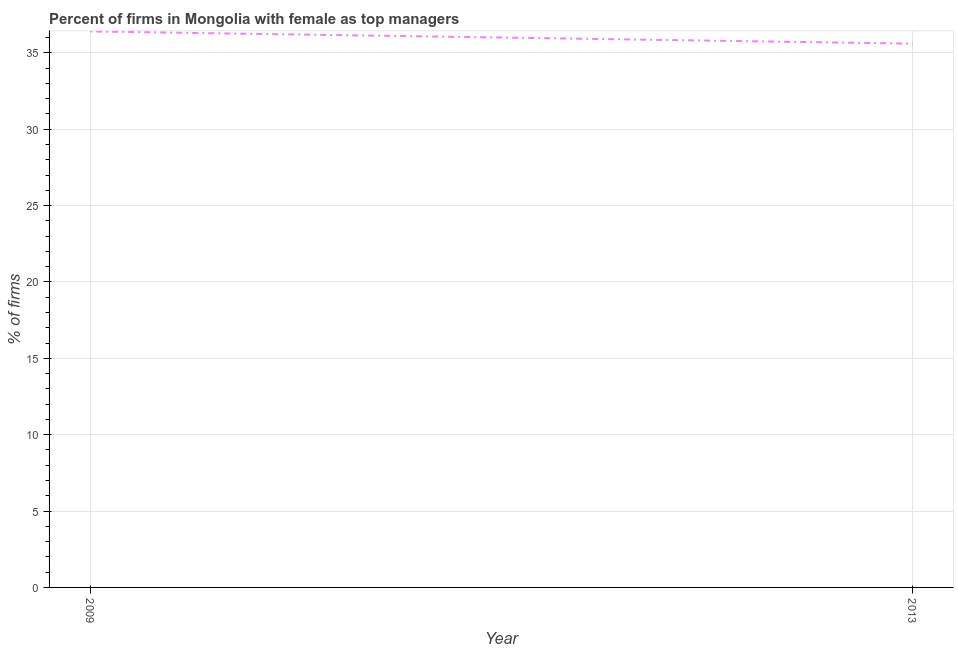What is the percentage of firms with female as top manager in 2009?
Your answer should be compact. 36.4. Across all years, what is the maximum percentage of firms with female as top manager?
Offer a very short reply. 36.4. Across all years, what is the minimum percentage of firms with female as top manager?
Provide a short and direct response. 35.6. What is the difference between the percentage of firms with female as top manager in 2009 and 2013?
Your answer should be compact. 0.8. What is the median percentage of firms with female as top manager?
Provide a succinct answer. 36. What is the ratio of the percentage of firms with female as top manager in 2009 to that in 2013?
Ensure brevity in your answer.  1.02. Is the percentage of firms with female as top manager in 2009 less than that in 2013?
Make the answer very short. No. Does the percentage of firms with female as top manager monotonically increase over the years?
Give a very brief answer. No. How many years are there in the graph?
Provide a short and direct response. 2. Does the graph contain grids?
Give a very brief answer. Yes. What is the title of the graph?
Offer a very short reply. Percent of firms in Mongolia with female as top managers. What is the label or title of the X-axis?
Keep it short and to the point. Year. What is the label or title of the Y-axis?
Offer a terse response. % of firms. What is the % of firms in 2009?
Provide a short and direct response. 36.4. What is the % of firms in 2013?
Your answer should be very brief. 35.6. What is the ratio of the % of firms in 2009 to that in 2013?
Offer a terse response. 1.02. 